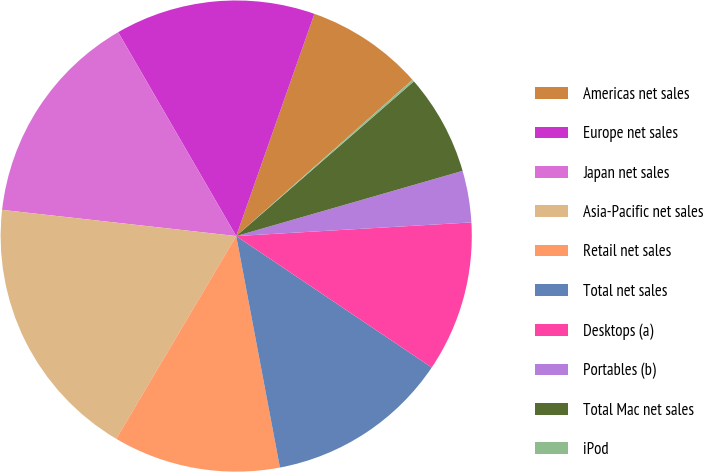Convert chart to OTSL. <chart><loc_0><loc_0><loc_500><loc_500><pie_chart><fcel>Americas net sales<fcel>Europe net sales<fcel>Japan net sales<fcel>Asia-Pacific net sales<fcel>Retail net sales<fcel>Total net sales<fcel>Desktops (a)<fcel>Portables (b)<fcel>Total Mac net sales<fcel>iPod<nl><fcel>8.07%<fcel>13.74%<fcel>14.87%<fcel>18.27%<fcel>11.47%<fcel>12.61%<fcel>10.34%<fcel>3.54%<fcel>6.94%<fcel>0.14%<nl></chart> 